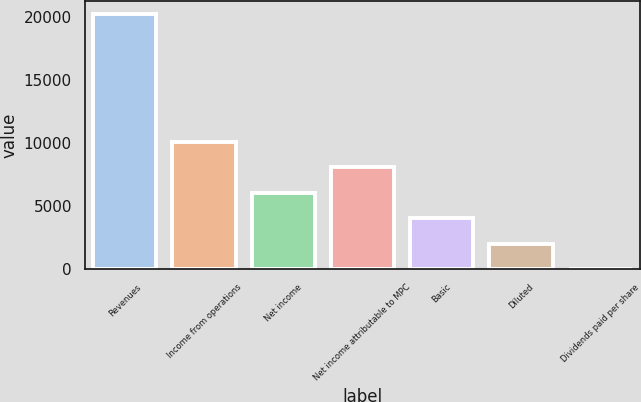<chart> <loc_0><loc_0><loc_500><loc_500><bar_chart><fcel>Revenues<fcel>Income from operations<fcel>Net income<fcel>Net income attributable to MPC<fcel>Basic<fcel>Diluted<fcel>Dividends paid per share<nl><fcel>20243<fcel>10121.6<fcel>6073.09<fcel>8097.36<fcel>4048.81<fcel>2024.53<fcel>0.25<nl></chart> 